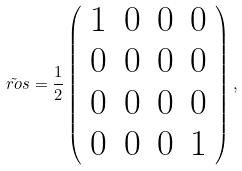Convert formula to latex. <formula><loc_0><loc_0><loc_500><loc_500>\tilde { \ r o s } = \frac { 1 } { 2 } \left ( \begin{array} { c c c c } 1 & 0 & 0 & 0 \\ 0 & 0 & 0 & 0 \\ 0 & 0 & 0 & 0 \\ 0 & 0 & 0 & 1 \end{array} \right ) ,</formula> 